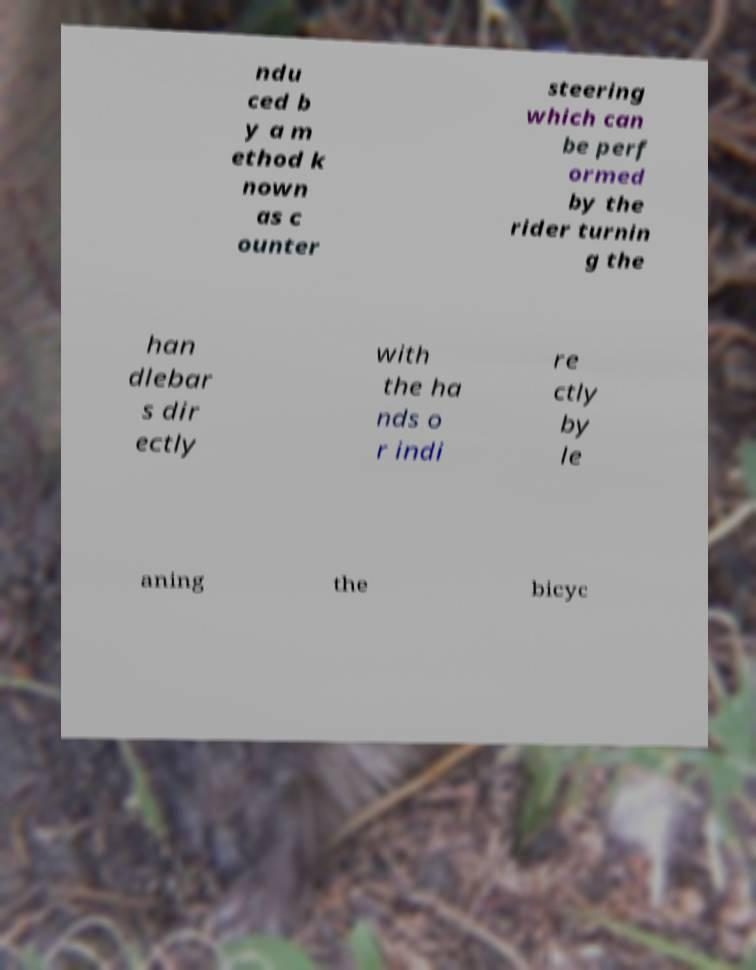Please read and relay the text visible in this image. What does it say? ndu ced b y a m ethod k nown as c ounter steering which can be perf ormed by the rider turnin g the han dlebar s dir ectly with the ha nds o r indi re ctly by le aning the bicyc 